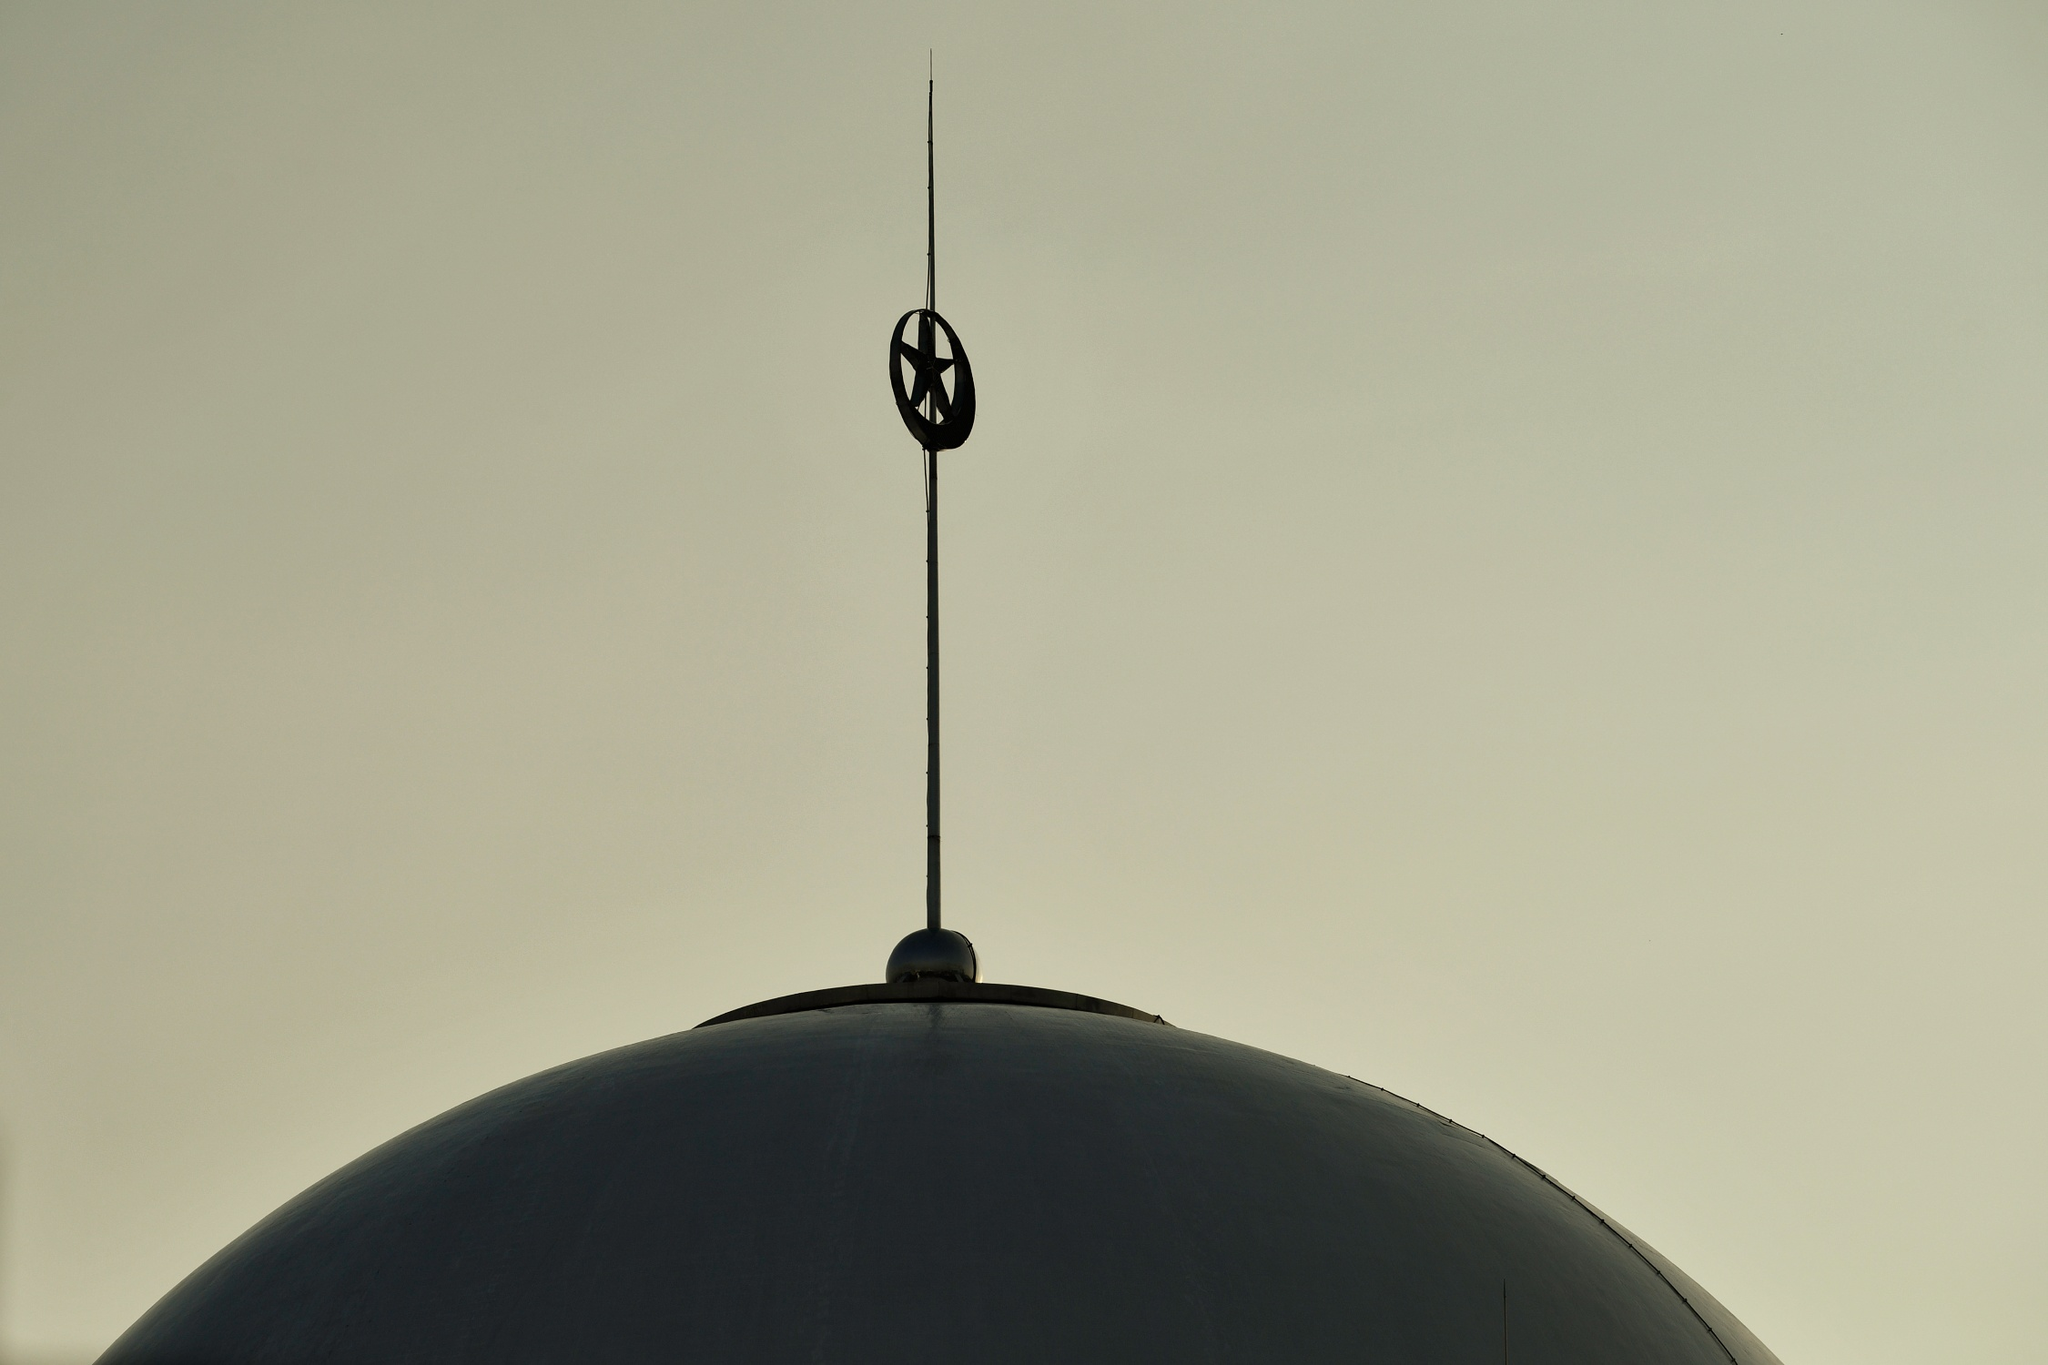What is the significance of the crescent moon symbol in architecture? The crescent moon is a widely recognized symbol in Islamic culture, often representing progress and enlightenment. When featured in architecture, particularly atop domes and spires, it signifies the building's religious purpose, serving as a symbol of faith and a reminder of Islam's historical and cultural heritage. It's a prominent feature in many mosques around the world. 